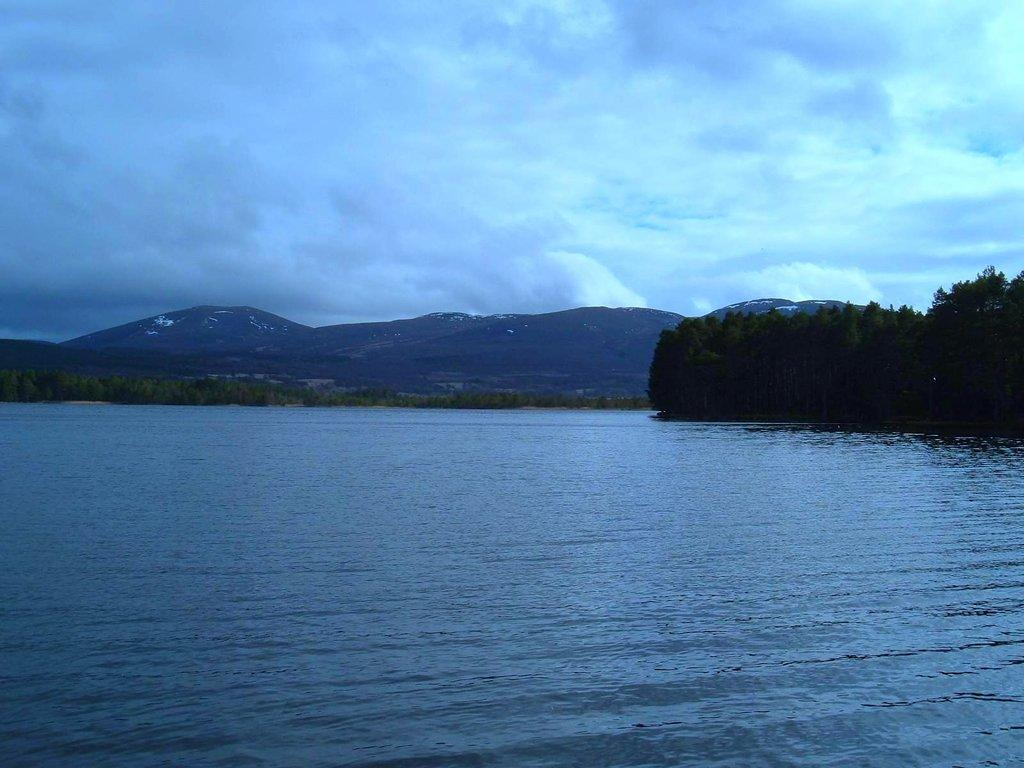What is visible in the image that is not solid? Water is visible in the image and is not solid. What type of vegetation can be seen in the image? There are trees in the image. What type of landscape feature is present in the image? There are hills in the image. What is visible in the background of the image? The sky is visible in the image. What can be seen in the sky in the image? Clouds are present in the sky. Can you tell me how many roots are visible in the image? There are no roots present in the image. What type of haircut is visible on the trees in the image? There are no haircuts present in the image; it features trees with their natural foliage. 